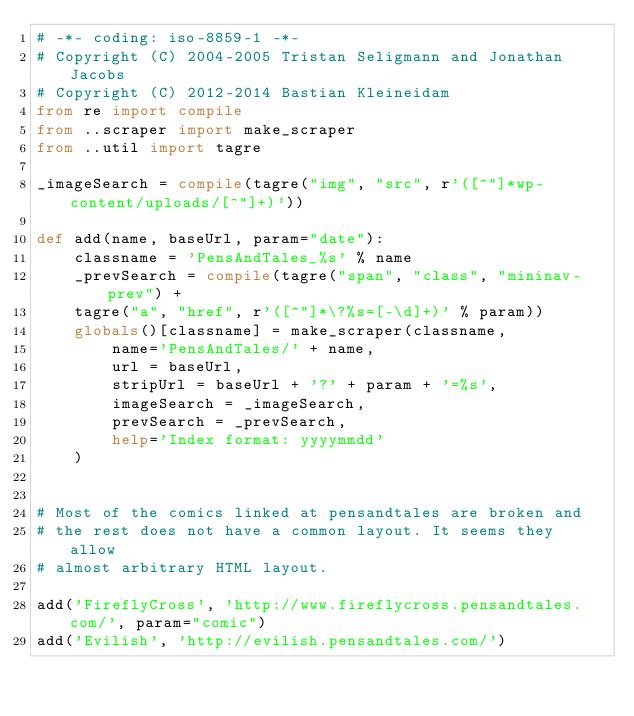<code> <loc_0><loc_0><loc_500><loc_500><_Python_># -*- coding: iso-8859-1 -*-
# Copyright (C) 2004-2005 Tristan Seligmann and Jonathan Jacobs
# Copyright (C) 2012-2014 Bastian Kleineidam
from re import compile
from ..scraper import make_scraper
from ..util import tagre

_imageSearch = compile(tagre("img", "src", r'([^"]*wp-content/uploads/[^"]+)'))

def add(name, baseUrl, param="date"):
    classname = 'PensAndTales_%s' % name
    _prevSearch = compile(tagre("span", "class", "mininav-prev") +
    tagre("a", "href", r'([^"]*\?%s=[-\d]+)' % param))
    globals()[classname] = make_scraper(classname,
        name='PensAndTales/' + name,
        url = baseUrl,
        stripUrl = baseUrl + '?' + param + '=%s',
        imageSearch = _imageSearch,
        prevSearch = _prevSearch,
        help='Index format: yyyymmdd'
    )


# Most of the comics linked at pensandtales are broken and
# the rest does not have a common layout. It seems they allow
# almost arbitrary HTML layout.

add('FireflyCross', 'http://www.fireflycross.pensandtales.com/', param="comic")
add('Evilish', 'http://evilish.pensandtales.com/')
</code> 